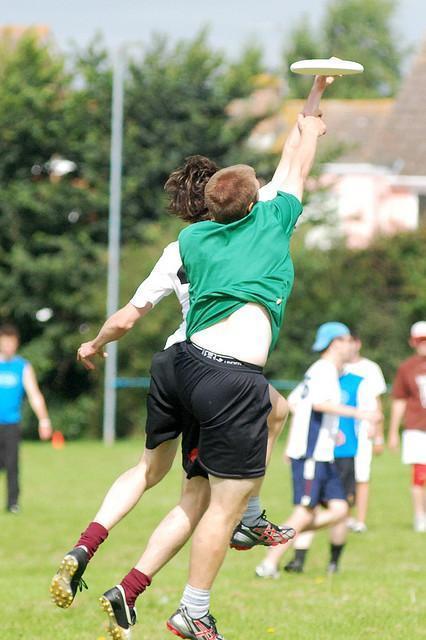How many people are there?
Give a very brief answer. 6. How many giraffes are holding their neck horizontally?
Give a very brief answer. 0. 